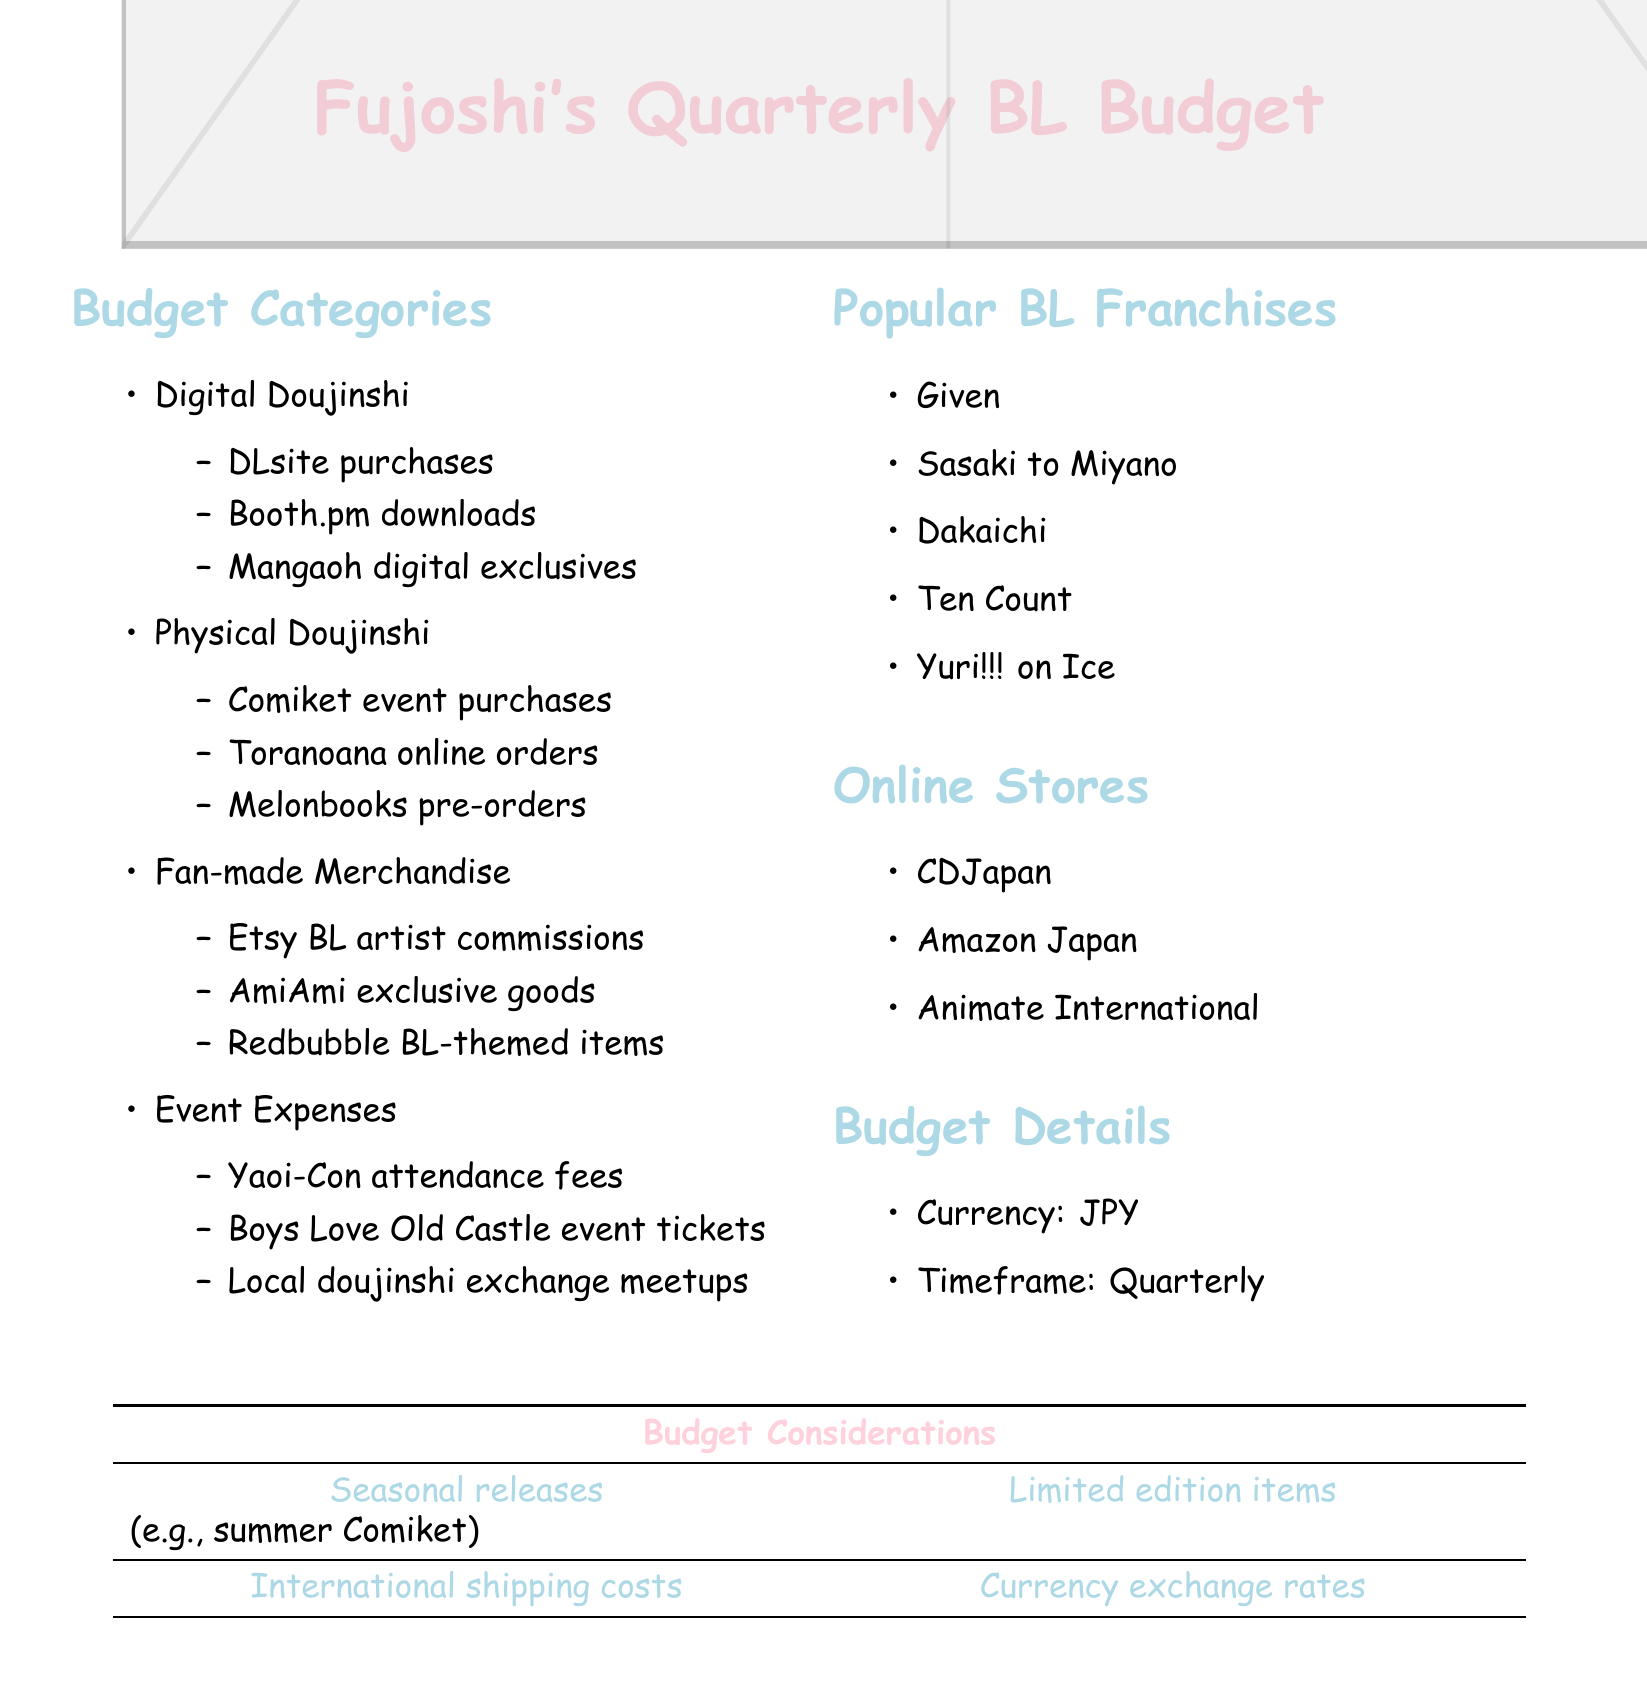What are the budget categories? The budget categories are listed in the document, including Digital Doujinshi, Physical Doujinshi, Fan-made Merchandise, and Event Expenses.
Answer: Digital Doujinshi, Physical Doujinshi, Fan-made Merchandise, Event Expenses Which online store is mentioned in the document? The document lists multiple online stores related to purchasing BL content; one of them is CDJapan.
Answer: CDJapan What is the currency used in the budget? The currency for the budget is specified in the document to be JPY.
Answer: JPY Name a popular BL franchise listed in the document. The document includes several popular BL franchises; one example is Given.
Answer: Given What type of events are included in the event expenses? The document mentions specific events related to Boys Love, one of which is Yaoi-Con.
Answer: Yaoi-Con Which store offers exclusive goods according to the document? The document states that AmiAmi is a source of exclusive goods.
Answer: AmiAmi What is the timeframe for the budget? The timeframe for the budget is stated clearly as quarterly.
Answer: Quarterly What is a budget consideration involving shipping? The document notes that international shipping costs are a consideration in the budget.
Answer: International shipping costs Which platform is used for purchasing digital doujinshi? The document mentions DLsite as a platform for purchasing digital doujinshi.
Answer: DLsite 